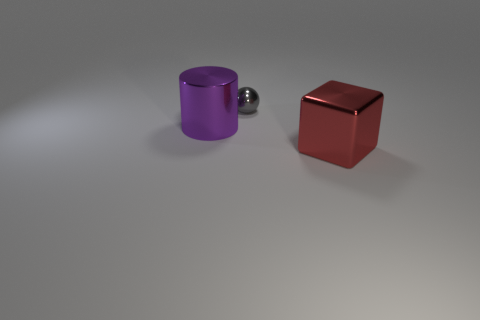Add 3 gray balls. How many objects exist? 6 Subtract all spheres. How many objects are left? 2 Add 3 small things. How many small things exist? 4 Subtract 0 purple spheres. How many objects are left? 3 Subtract all tiny green rubber objects. Subtract all purple metallic cylinders. How many objects are left? 2 Add 1 tiny things. How many tiny things are left? 2 